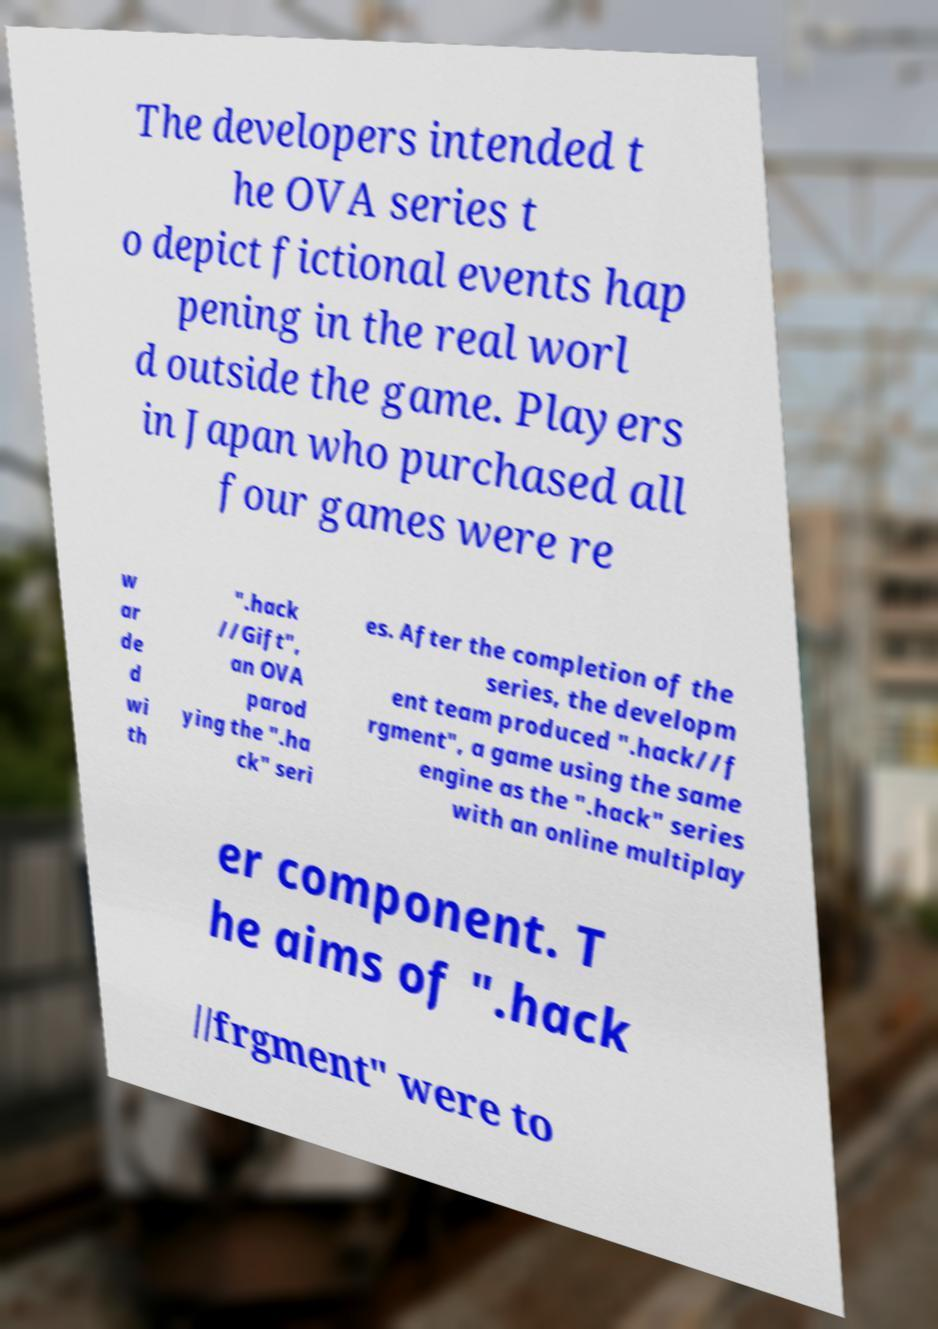There's text embedded in this image that I need extracted. Can you transcribe it verbatim? The developers intended t he OVA series t o depict fictional events hap pening in the real worl d outside the game. Players in Japan who purchased all four games were re w ar de d wi th ".hack //Gift", an OVA parod ying the ".ha ck" seri es. After the completion of the series, the developm ent team produced ".hack//f rgment", a game using the same engine as the ".hack" series with an online multiplay er component. T he aims of ".hack //frgment" were to 